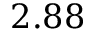Convert formula to latex. <formula><loc_0><loc_0><loc_500><loc_500>2 . 8 8</formula> 